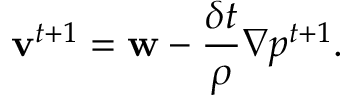Convert formula to latex. <formula><loc_0><loc_0><loc_500><loc_500>v ^ { t + 1 } = w - \frac { \delta t } { \rho } \nabla p ^ { t + 1 } .</formula> 